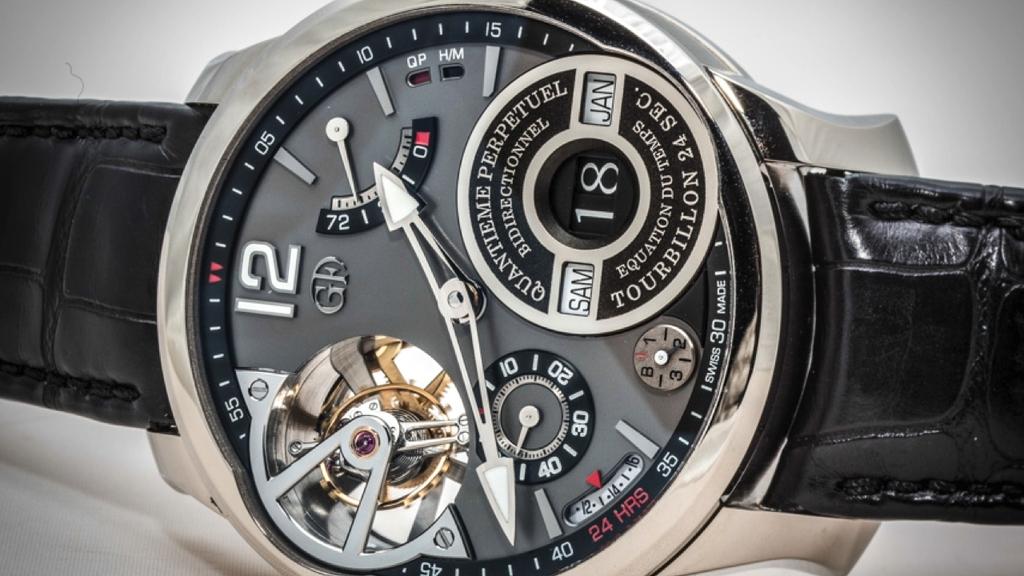What number is indicated in the smaller circle within the watch?
Make the answer very short. 18. What is the date on the  watch?
Your answer should be very brief. Jan 18. 